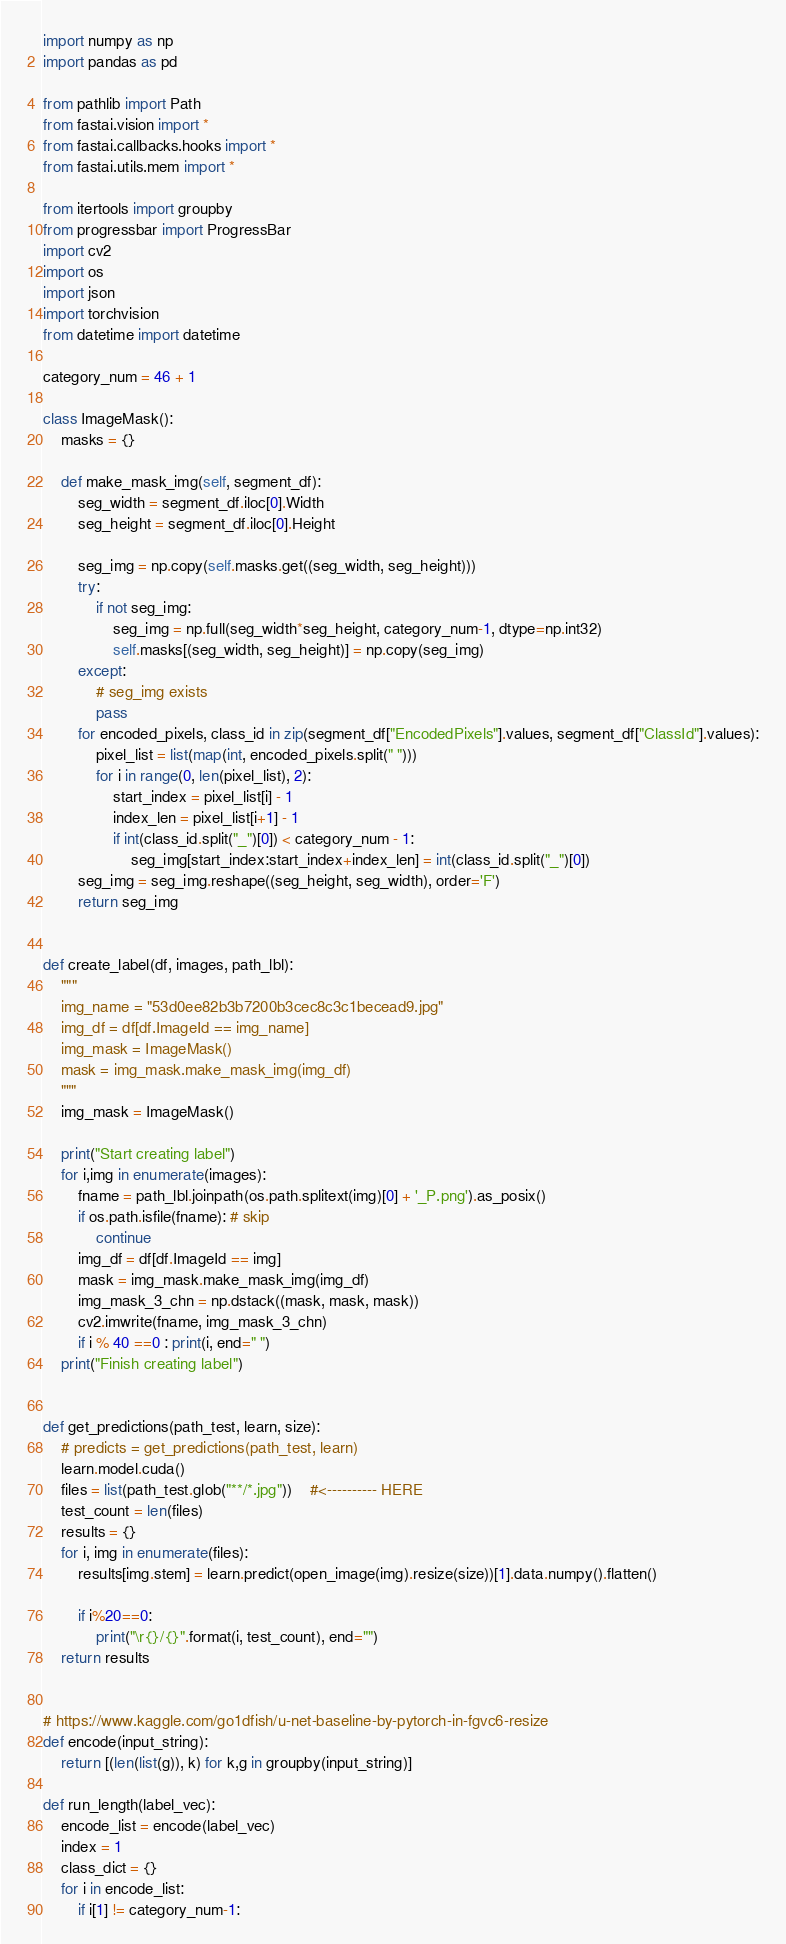Convert code to text. <code><loc_0><loc_0><loc_500><loc_500><_Python_>
import numpy as np
import pandas as pd

from pathlib import Path
from fastai.vision import *
from fastai.callbacks.hooks import *
from fastai.utils.mem import *

from itertools import groupby
from progressbar import ProgressBar
import cv2
import os
import json
import torchvision
from datetime import datetime

category_num = 46 + 1

class ImageMask():
    masks = {}
    
    def make_mask_img(self, segment_df):
        seg_width = segment_df.iloc[0].Width
        seg_height = segment_df.iloc[0].Height
        
        seg_img = np.copy(self.masks.get((seg_width, seg_height)))
        try:
            if not seg_img:
                seg_img = np.full(seg_width*seg_height, category_num-1, dtype=np.int32)
                self.masks[(seg_width, seg_height)] = np.copy(seg_img)
        except:
            # seg_img exists
            pass
        for encoded_pixels, class_id in zip(segment_df["EncodedPixels"].values, segment_df["ClassId"].values):
            pixel_list = list(map(int, encoded_pixels.split(" ")))
            for i in range(0, len(pixel_list), 2):
                start_index = pixel_list[i] - 1
                index_len = pixel_list[i+1] - 1
                if int(class_id.split("_")[0]) < category_num - 1:
                    seg_img[start_index:start_index+index_len] = int(class_id.split("_")[0])
        seg_img = seg_img.reshape((seg_height, seg_width), order='F')
        return seg_img
        

def create_label(df, images, path_lbl):
    """
    img_name = "53d0ee82b3b7200b3cec8c3c1becead9.jpg"
    img_df = df[df.ImageId == img_name]
    img_mask = ImageMask()
    mask = img_mask.make_mask_img(img_df)
    """
    img_mask = ImageMask()

    print("Start creating label")
    for i,img in enumerate(images):
        fname = path_lbl.joinpath(os.path.splitext(img)[0] + '_P.png').as_posix()
        if os.path.isfile(fname): # skip
            continue
        img_df = df[df.ImageId == img]
        mask = img_mask.make_mask_img(img_df)
        img_mask_3_chn = np.dstack((mask, mask, mask))
        cv2.imwrite(fname, img_mask_3_chn)
        if i % 40 ==0 : print(i, end=" ")
    print("Finish creating label")
            
        
def get_predictions(path_test, learn, size):
    # predicts = get_predictions(path_test, learn)
    learn.model.cuda()
    files = list(path_test.glob("**/*.jpg"))    #<---------- HERE
    test_count = len(files)
    results = {}
    for i, img in enumerate(files):
        results[img.stem] = learn.predict(open_image(img).resize(size))[1].data.numpy().flatten()
    
        if i%20==0:
            print("\r{}/{}".format(i, test_count), end="")
    return results       
        

# https://www.kaggle.com/go1dfish/u-net-baseline-by-pytorch-in-fgvc6-resize
def encode(input_string):
    return [(len(list(g)), k) for k,g in groupby(input_string)]

def run_length(label_vec):
    encode_list = encode(label_vec)
    index = 1
    class_dict = {}
    for i in encode_list:
        if i[1] != category_num-1:</code> 